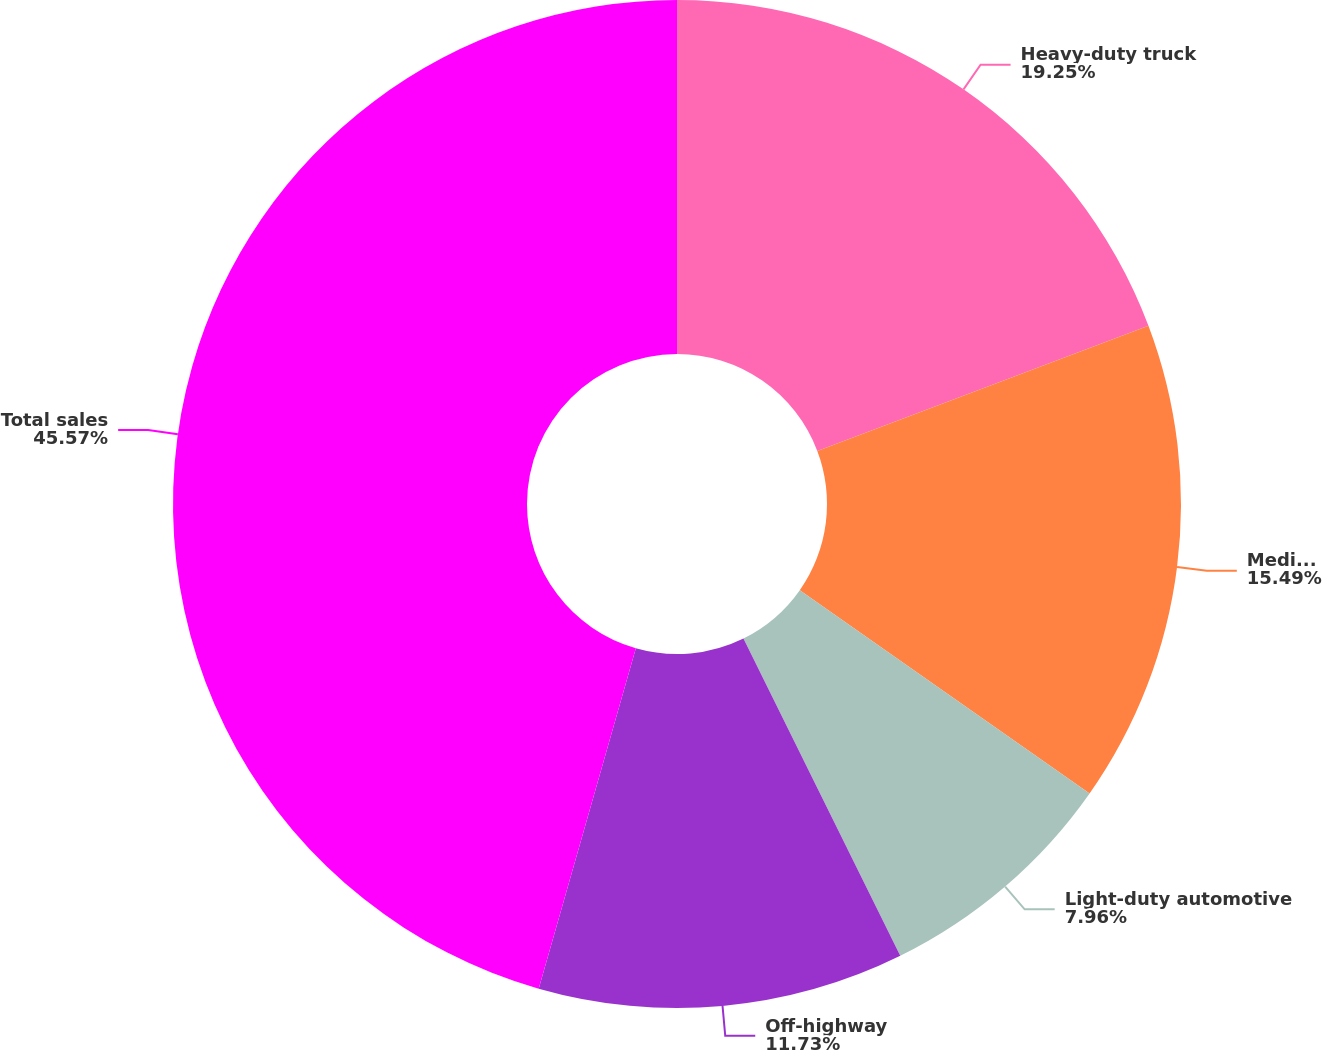Convert chart. <chart><loc_0><loc_0><loc_500><loc_500><pie_chart><fcel>Heavy-duty truck<fcel>Medium-duty truck and bus<fcel>Light-duty automotive<fcel>Off-highway<fcel>Total sales<nl><fcel>19.25%<fcel>15.49%<fcel>7.96%<fcel>11.73%<fcel>45.58%<nl></chart> 